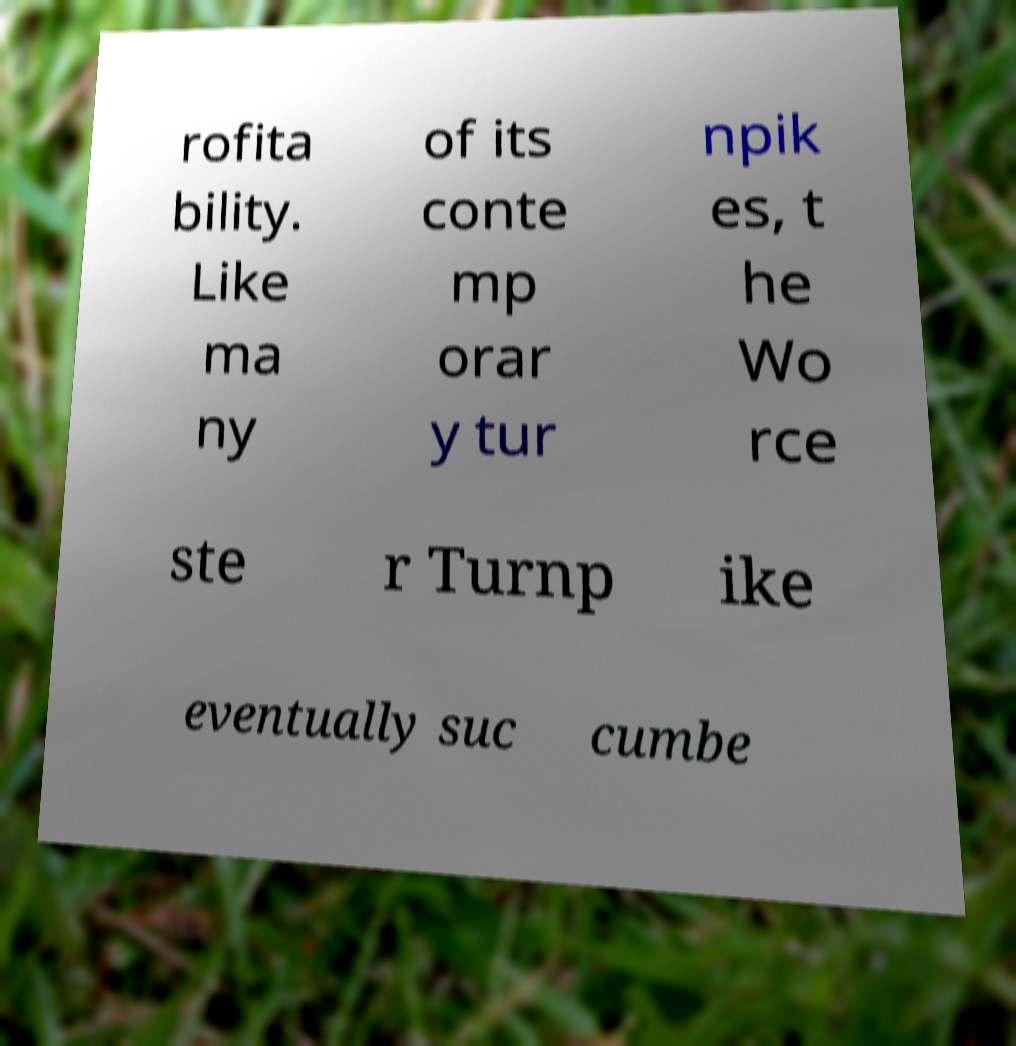Can you read and provide the text displayed in the image?This photo seems to have some interesting text. Can you extract and type it out for me? rofita bility. Like ma ny of its conte mp orar y tur npik es, t he Wo rce ste r Turnp ike eventually suc cumbe 